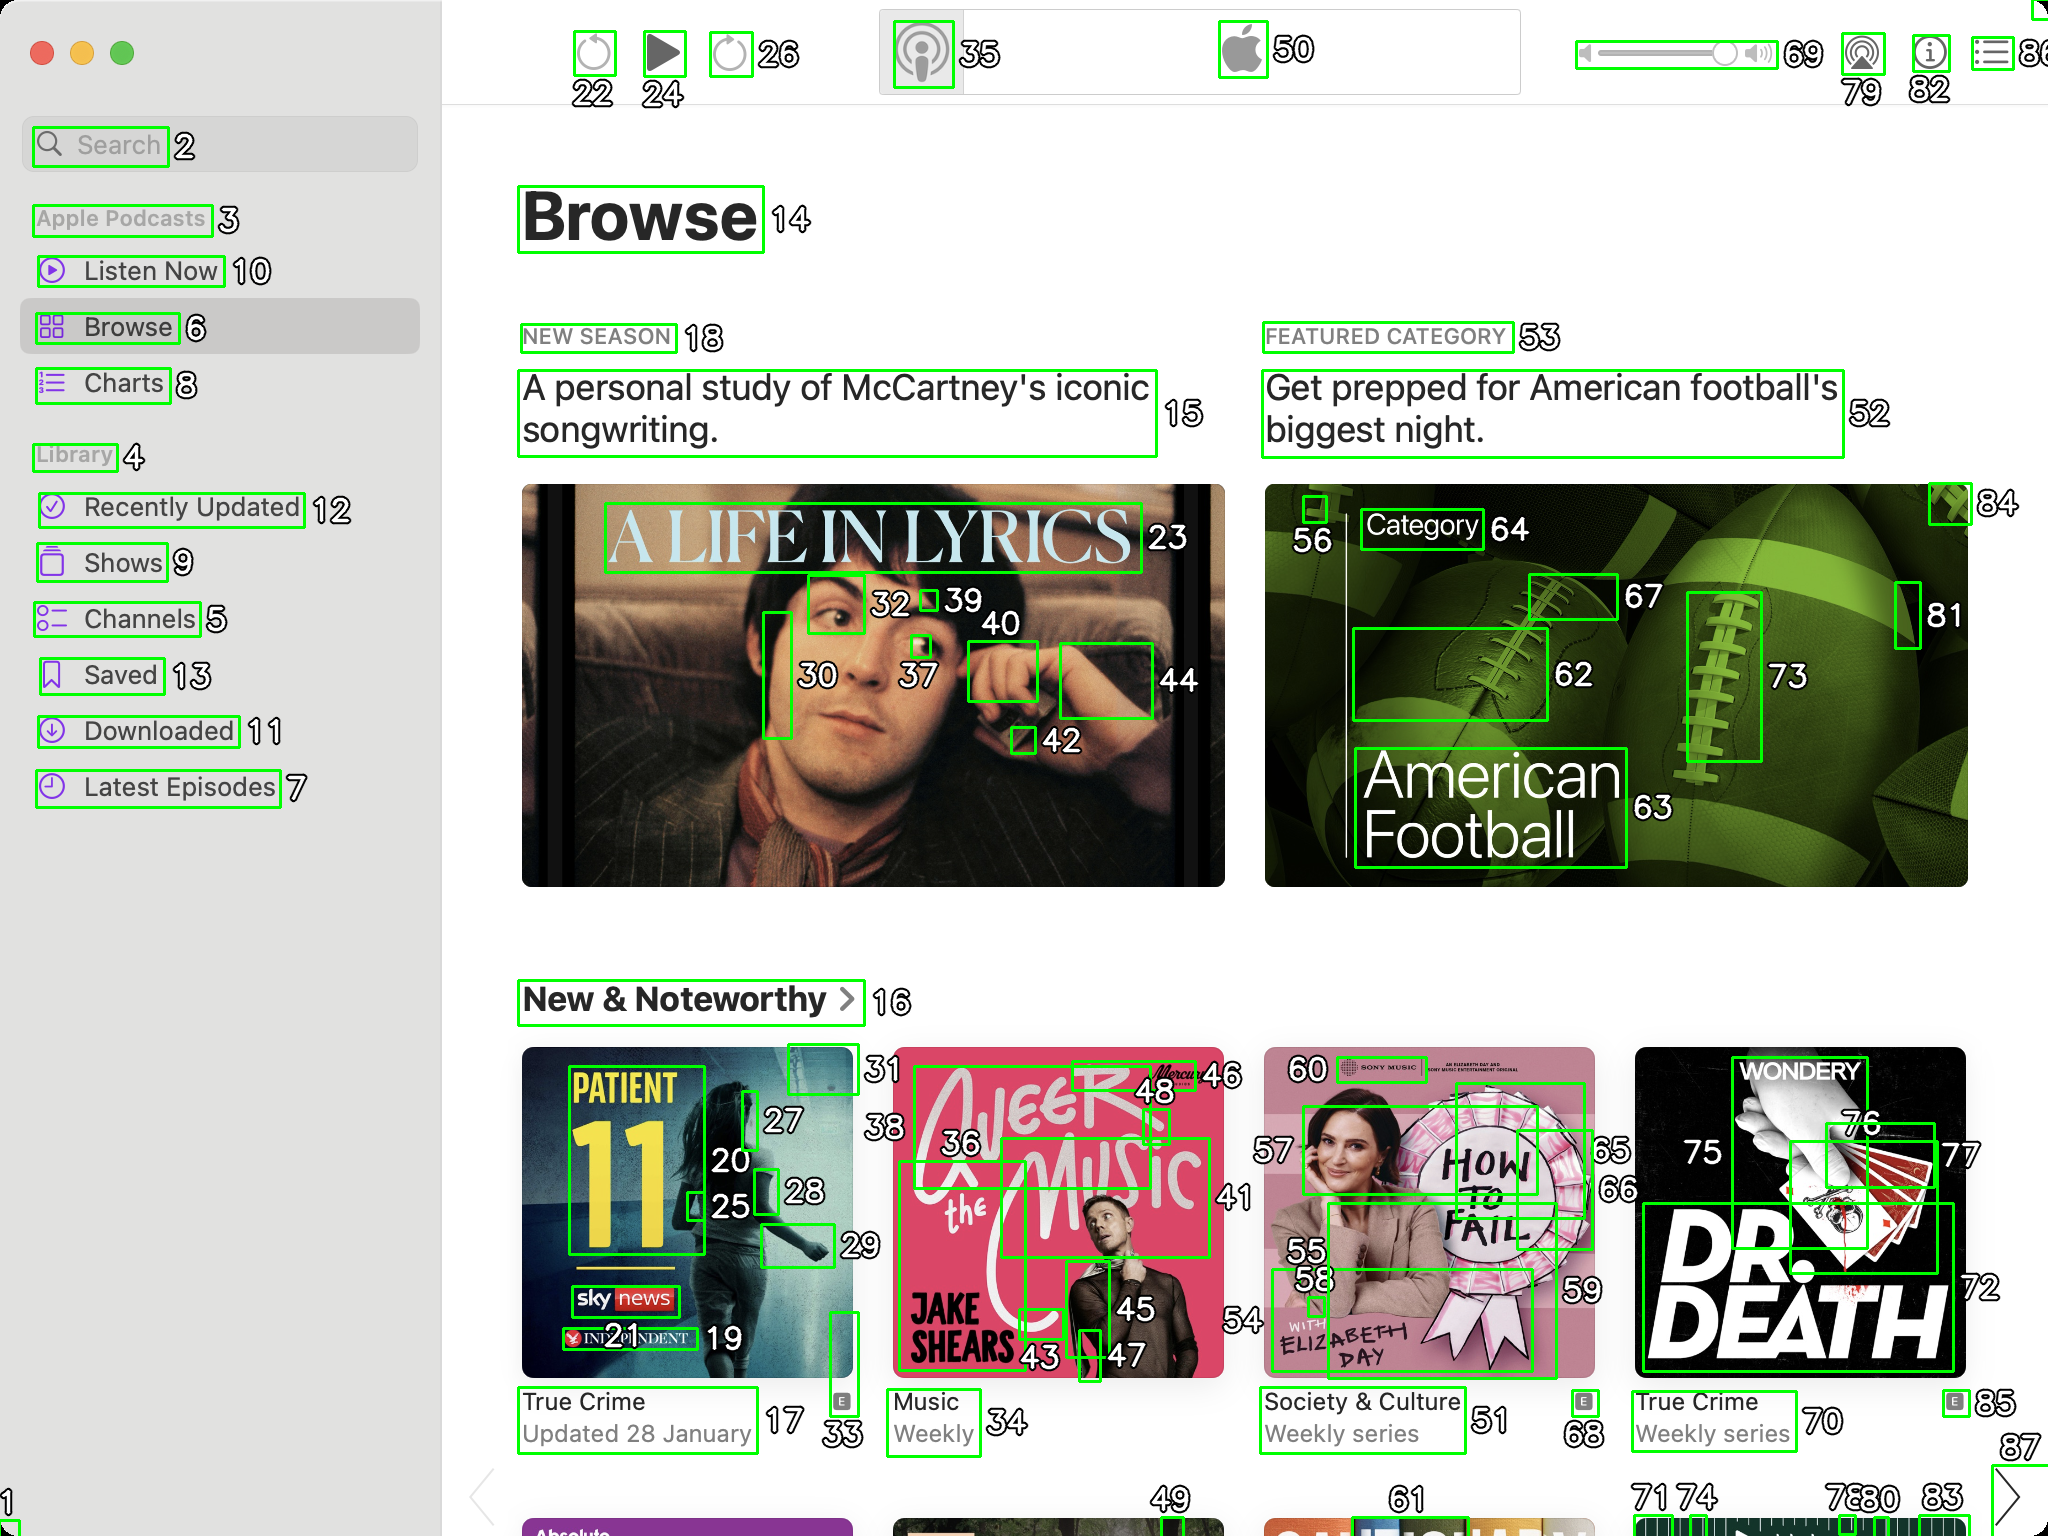You are an AI designed for image processing and segmentation analysis, particularly skilled in merging segmented regions of an image to improve accuracy and readability.

**Task Description:**
Your task is to address a user's concern with a UI screenshot of the Apple Podcasts application on MacOS. The screenshot contains multiple green boxes, each representing a UI element, with a unique white number outlined in black ranging from 1 to 88. Due to segmentation issues, some boxes that belong to the same image are divided unnaturally.

**Objective:**
Merge these segmented areas that correspond to a single UI element to create a coherent representation. The final output should be in JSON format, where each key-value pair represents the merged areas.

**Example JSON Output:**
If boxes with numbers 1, 2, and 3 should belong to the same UI element, the JSON output should be:

```json
{
    "Image A Life In Lyrics": [1, 2, 3]
}
```

**Instructions:**

- **Identify Segmented Regions:** Analyze the screenshot to identify which green boxes belong to the same UI element.
- **Merge Regions:** Group the numbers of these boxes together to represent a single UI element.
- **Output Format:** Produce the output in JSON format, with each key representing a UI element and each value being a list of the numbers of the merged boxes. Don't include in the result UI elements that consist of one box.

**Primary Objective:**
Ensure the accuracy of the merged regions based on the user's supplied image information, maintaining the integrity and structure of the UI elements in the Apple Podcasts application on MacOS. ```json
{
    "Browse": [14],
    "New Season": [18],
    "A Life In Lyrics": [23, 30, 32, 37, 39, 42, 44],
    "Featured Category": [53],
    "Get prepped for American football's biggest night.": [52],
    "Category": [64],
    "American Football": [62, 63, 67, 72, 73, 76],
    "New & Noteworthy": [16],
    "Patient 11": [27],
    "Queer": [46],
    "The Music": [41, 45, 54],
    "Jake Shears": [43],
    "Society & Culture": [51, 61],
    "True Crime": [68, 70, 87],
    "7:30 B.R.": [83]
}
``` 